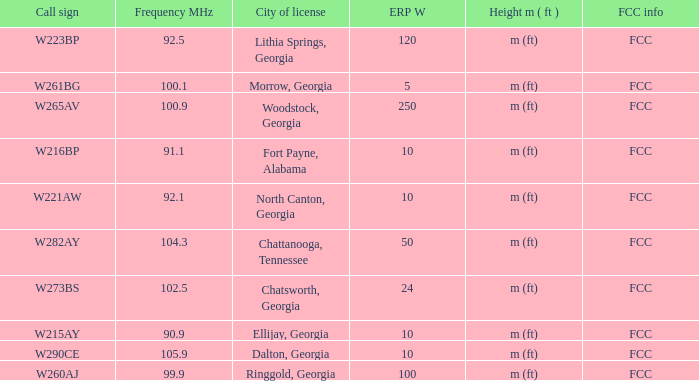What is the number of Frequency MHz in woodstock, georgia? 100.9. 